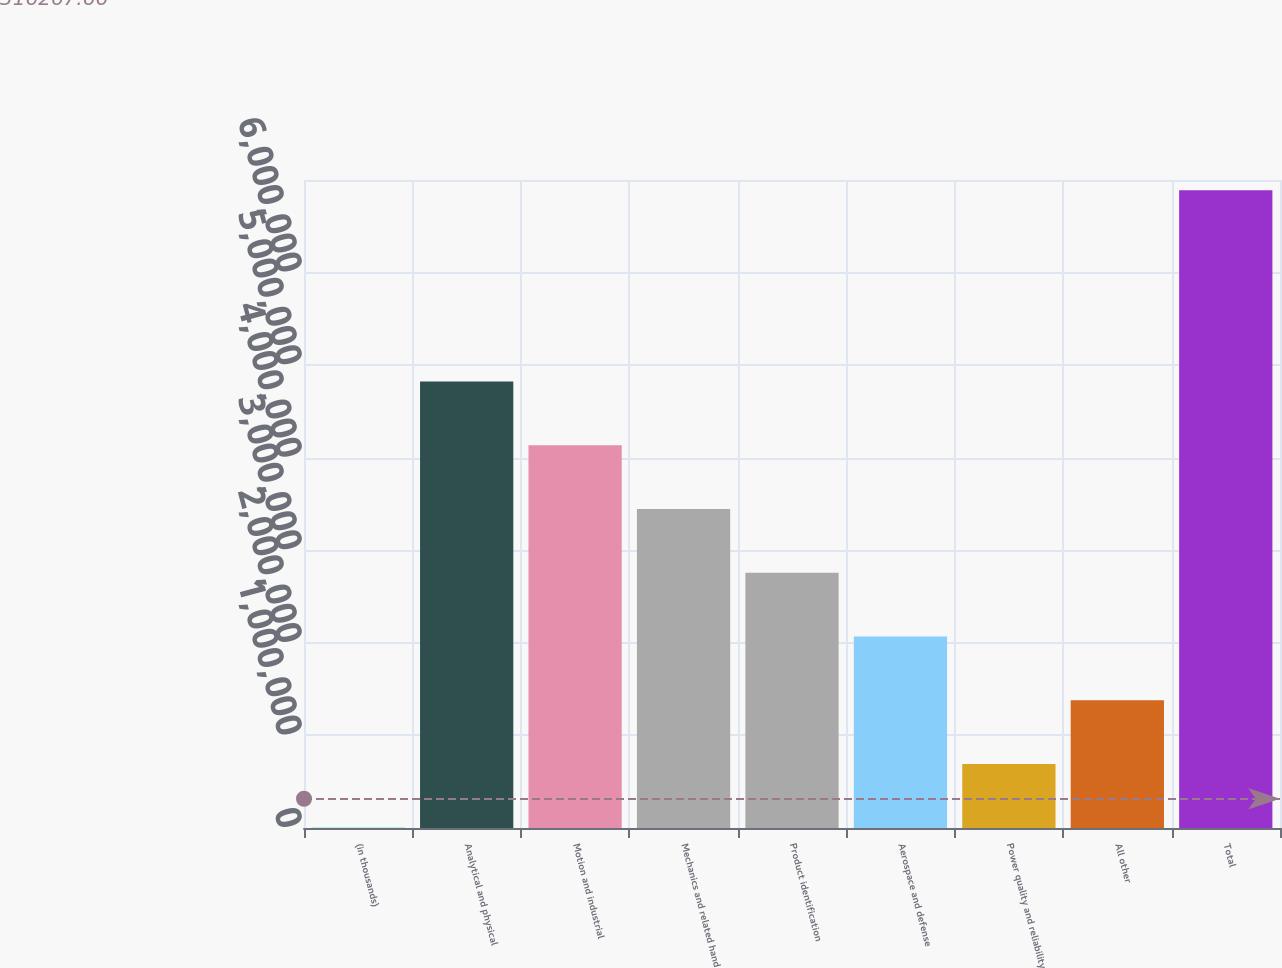<chart> <loc_0><loc_0><loc_500><loc_500><bar_chart><fcel>(in thousands)<fcel>Analytical and physical<fcel>Motion and industrial<fcel>Mechanics and related hand<fcel>Product identification<fcel>Aerospace and defense<fcel>Power quality and reliability<fcel>All other<fcel>Total<nl><fcel>2004<fcel>4.82311e+06<fcel>4.13438e+06<fcel>3.44565e+06<fcel>2.75692e+06<fcel>2.06819e+06<fcel>690734<fcel>1.37946e+06<fcel>6.8893e+06<nl></chart> 